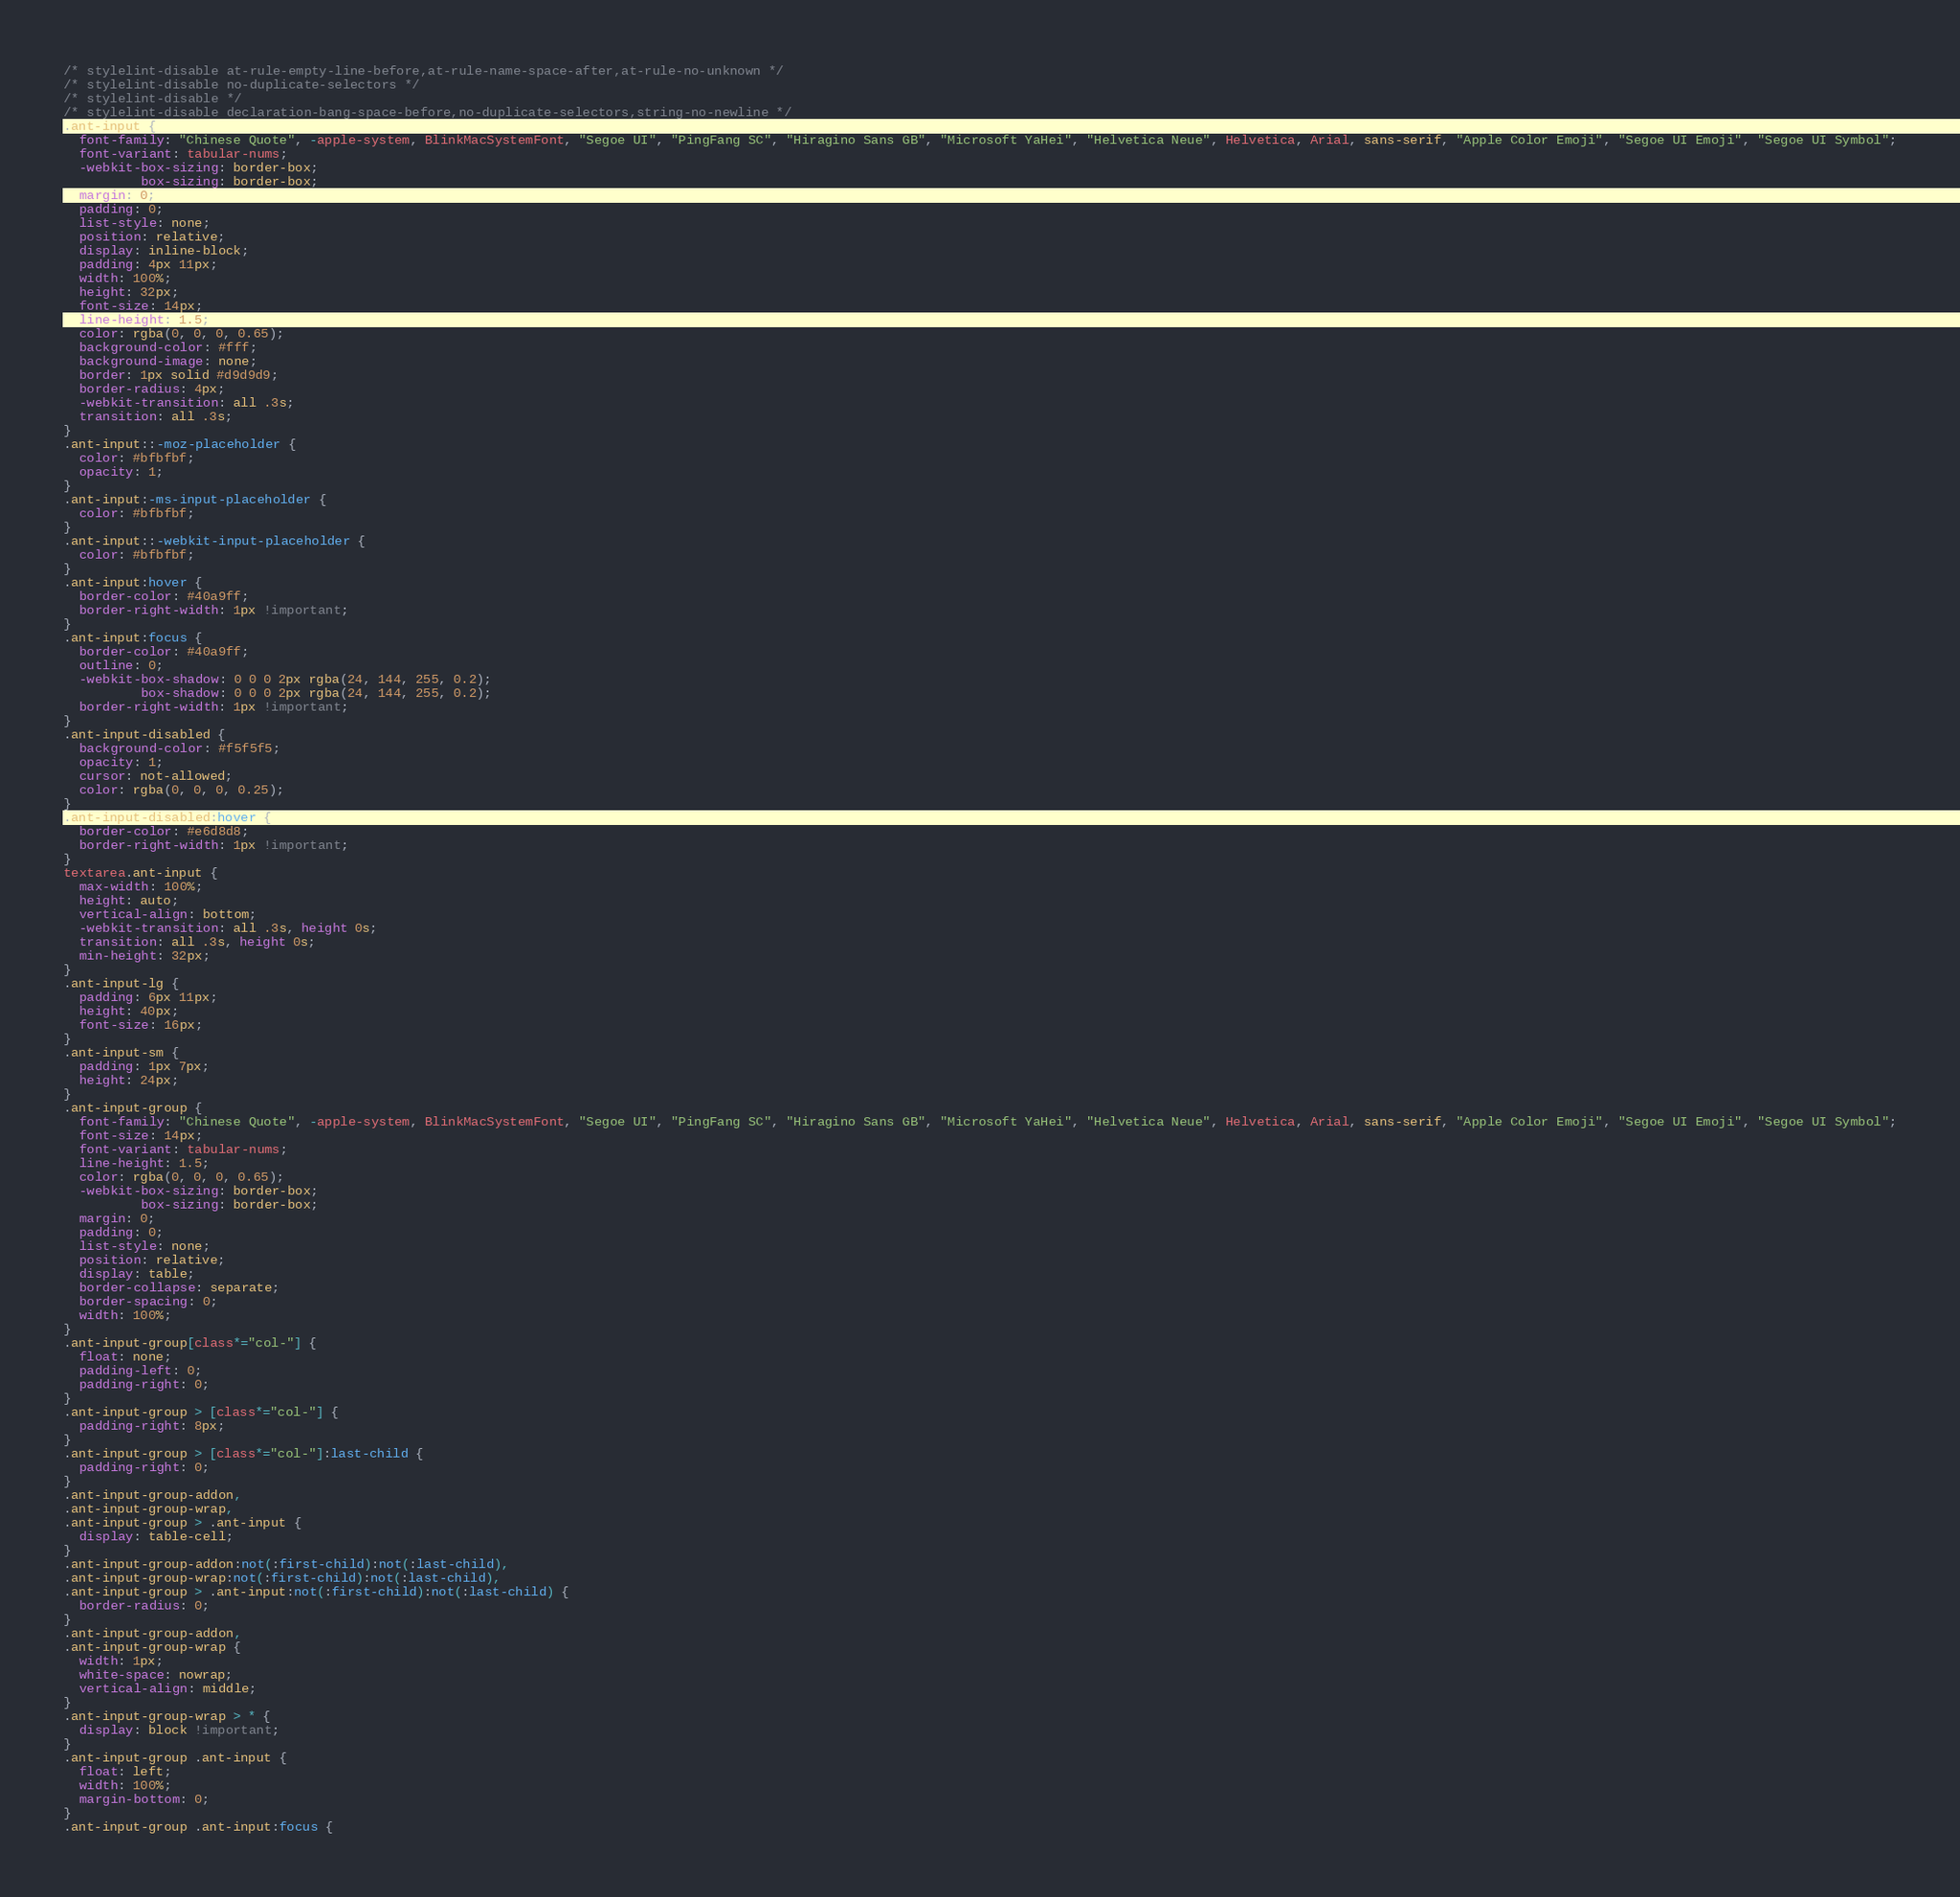<code> <loc_0><loc_0><loc_500><loc_500><_CSS_>/* stylelint-disable at-rule-empty-line-before,at-rule-name-space-after,at-rule-no-unknown */
/* stylelint-disable no-duplicate-selectors */
/* stylelint-disable */
/* stylelint-disable declaration-bang-space-before,no-duplicate-selectors,string-no-newline */
.ant-input {
  font-family: "Chinese Quote", -apple-system, BlinkMacSystemFont, "Segoe UI", "PingFang SC", "Hiragino Sans GB", "Microsoft YaHei", "Helvetica Neue", Helvetica, Arial, sans-serif, "Apple Color Emoji", "Segoe UI Emoji", "Segoe UI Symbol";
  font-variant: tabular-nums;
  -webkit-box-sizing: border-box;
          box-sizing: border-box;
  margin: 0;
  padding: 0;
  list-style: none;
  position: relative;
  display: inline-block;
  padding: 4px 11px;
  width: 100%;
  height: 32px;
  font-size: 14px;
  line-height: 1.5;
  color: rgba(0, 0, 0, 0.65);
  background-color: #fff;
  background-image: none;
  border: 1px solid #d9d9d9;
  border-radius: 4px;
  -webkit-transition: all .3s;
  transition: all .3s;
}
.ant-input::-moz-placeholder {
  color: #bfbfbf;
  opacity: 1;
}
.ant-input:-ms-input-placeholder {
  color: #bfbfbf;
}
.ant-input::-webkit-input-placeholder {
  color: #bfbfbf;
}
.ant-input:hover {
  border-color: #40a9ff;
  border-right-width: 1px !important;
}
.ant-input:focus {
  border-color: #40a9ff;
  outline: 0;
  -webkit-box-shadow: 0 0 0 2px rgba(24, 144, 255, 0.2);
          box-shadow: 0 0 0 2px rgba(24, 144, 255, 0.2);
  border-right-width: 1px !important;
}
.ant-input-disabled {
  background-color: #f5f5f5;
  opacity: 1;
  cursor: not-allowed;
  color: rgba(0, 0, 0, 0.25);
}
.ant-input-disabled:hover {
  border-color: #e6d8d8;
  border-right-width: 1px !important;
}
textarea.ant-input {
  max-width: 100%;
  height: auto;
  vertical-align: bottom;
  -webkit-transition: all .3s, height 0s;
  transition: all .3s, height 0s;
  min-height: 32px;
}
.ant-input-lg {
  padding: 6px 11px;
  height: 40px;
  font-size: 16px;
}
.ant-input-sm {
  padding: 1px 7px;
  height: 24px;
}
.ant-input-group {
  font-family: "Chinese Quote", -apple-system, BlinkMacSystemFont, "Segoe UI", "PingFang SC", "Hiragino Sans GB", "Microsoft YaHei", "Helvetica Neue", Helvetica, Arial, sans-serif, "Apple Color Emoji", "Segoe UI Emoji", "Segoe UI Symbol";
  font-size: 14px;
  font-variant: tabular-nums;
  line-height: 1.5;
  color: rgba(0, 0, 0, 0.65);
  -webkit-box-sizing: border-box;
          box-sizing: border-box;
  margin: 0;
  padding: 0;
  list-style: none;
  position: relative;
  display: table;
  border-collapse: separate;
  border-spacing: 0;
  width: 100%;
}
.ant-input-group[class*="col-"] {
  float: none;
  padding-left: 0;
  padding-right: 0;
}
.ant-input-group > [class*="col-"] {
  padding-right: 8px;
}
.ant-input-group > [class*="col-"]:last-child {
  padding-right: 0;
}
.ant-input-group-addon,
.ant-input-group-wrap,
.ant-input-group > .ant-input {
  display: table-cell;
}
.ant-input-group-addon:not(:first-child):not(:last-child),
.ant-input-group-wrap:not(:first-child):not(:last-child),
.ant-input-group > .ant-input:not(:first-child):not(:last-child) {
  border-radius: 0;
}
.ant-input-group-addon,
.ant-input-group-wrap {
  width: 1px;
  white-space: nowrap;
  vertical-align: middle;
}
.ant-input-group-wrap > * {
  display: block !important;
}
.ant-input-group .ant-input {
  float: left;
  width: 100%;
  margin-bottom: 0;
}
.ant-input-group .ant-input:focus {</code> 